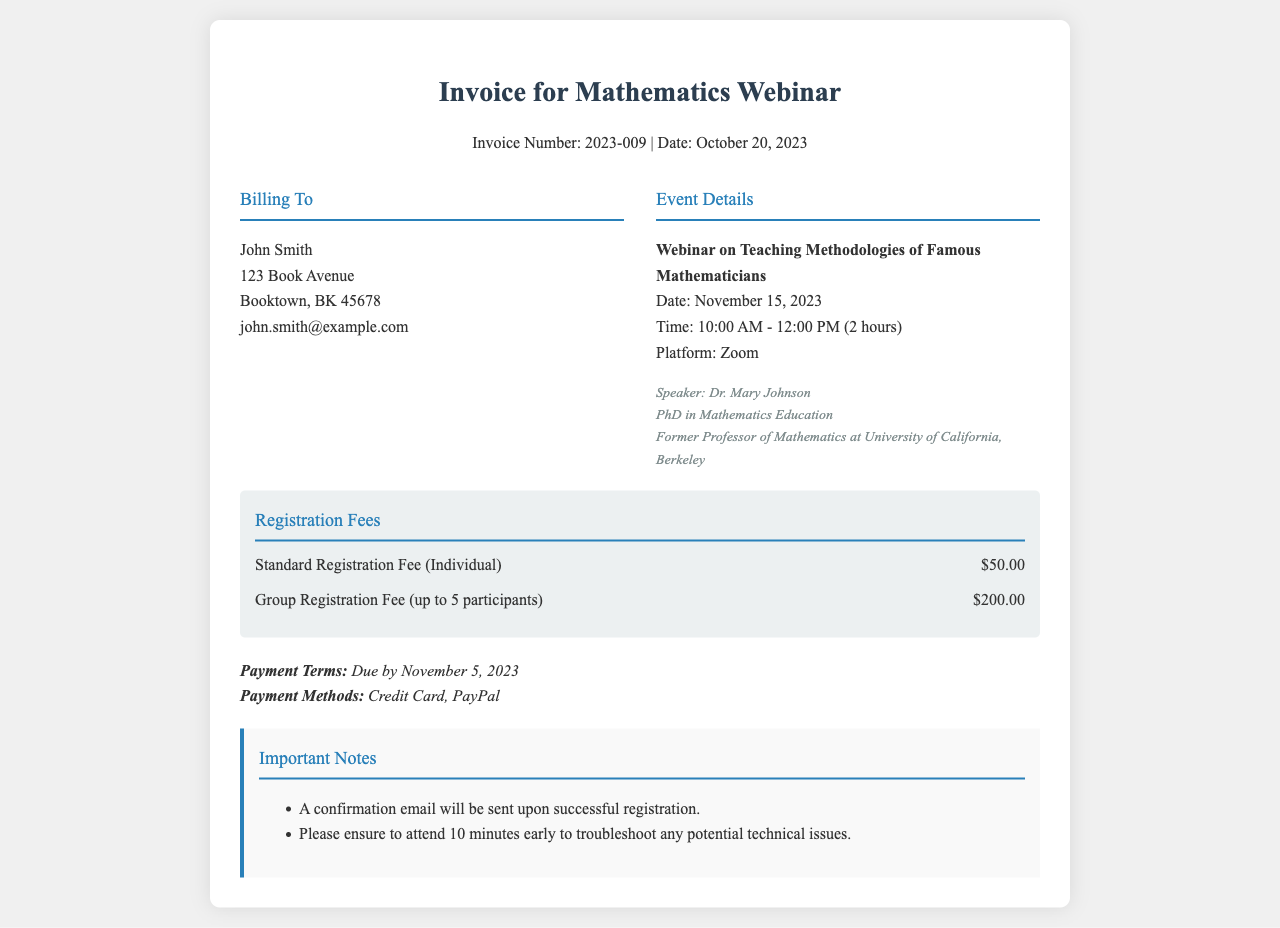What is the invoice number? The invoice number is listed at the top of the document under the title section.
Answer: 2023-009 What is the standard registration fee? The standard registration fee is detailed in the fees section of the document.
Answer: $50.00 Who is the speaker for the webinar? The speaker's name is mentioned in the event details section.
Answer: Dr. Mary Johnson When is the payment due? The payment terms section specifies when the payment must be made.
Answer: November 5, 2023 What platform will the webinar be held on? The platform for the webinar is mentioned in the event details.
Answer: Zoom What is the duration of the webinar? The duration is specified in the event details section of the document.
Answer: 2 hours What is the group registration fee for up to 5 participants? The group registration fee is listed among the fees.
Answer: $200.00 How many minutes early should participants log in? The notes section provides guidance on when to log in for the event.
Answer: 10 minutes What is the education qualification of the speaker? The speaker's education qualification is provided under the speaker information.
Answer: PhD in Mathematics Education 